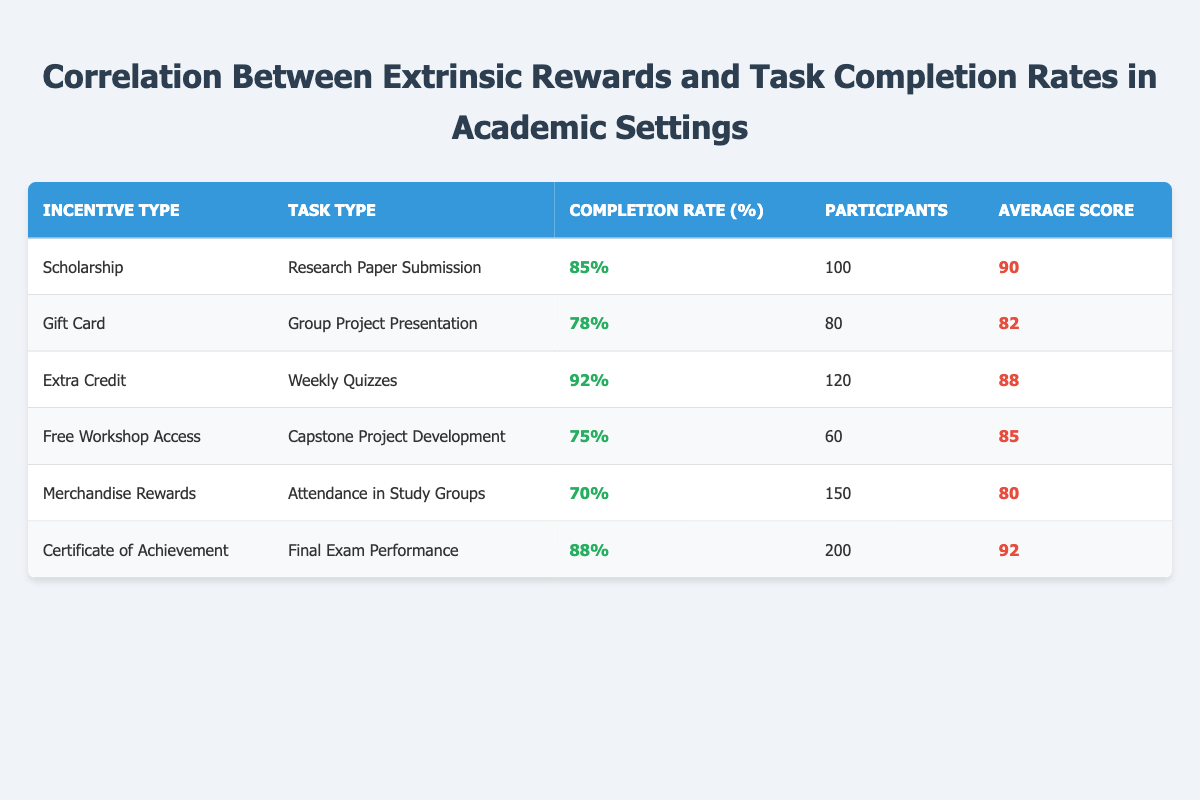What is the completion rate for the Extra Credit incentive? The table directly shows the completion rate under the "Completion Rate (%)" column for the "Extra Credit" row, which is 92%.
Answer: 92% Which task type has the highest average score? By reviewing the "Average Score" column, the highest value is found in the "Certificate of Achievement" row with a score of 92.
Answer: Final Exam Performance What is the total number of participants for tasks with a completion rate above 80%? The tasks with completion rates above 80% are "Research Paper Submission" (100 participants), "Weekly Quizzes" (120 participants), and "Final Exam Performance" (200 participants). Summing these gives us 100 + 120 + 200 = 420 participants.
Answer: 420 Is the completion rate for the Merchandise Rewards incentive greater than 75%? Looking at the "Completion Rate (%)" for "Merchandise Rewards," which is 70%, it is indeed less than 75%.
Answer: No What is the average completion rate for all task types listed in the table? To find the average completion rate, sum all completion rates: 85 + 78 + 92 + 75 + 70 + 88 = 408. Then divide by the number of tasks, which is 6. Thus, 408 / 6 = 68.
Answer: 68 Which incentive type has the lowest completion rate and what is that rate? Scanning the completion rates, the "Merchandise Rewards" has the lowest rate at 70%.
Answer: Merchandise Rewards and 70 How many more participants were involved in the "Certificate of Achievement" task compared to the "Free Workshop Access"? The "Certificate of Achievement" has 200 participants, while "Free Workshop Access" has 60 participants. Calculating the difference gives us 200 - 60 = 140 more participants.
Answer: 140 What is the average score for tasks with completion rates below 80%? The tasks below 80% are "Gift Card" (average score of 82), "Free Workshop Access" (85), and "Merchandise Rewards" (80). Summing these gives 82 + 85 + 80 = 247. There are 3 tasks, so the average is 247/3 = 82.33, rounded down is 82.
Answer: 82 